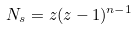<formula> <loc_0><loc_0><loc_500><loc_500>N _ { s } = z ( z - 1 ) ^ { n - 1 }</formula> 